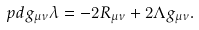<formula> <loc_0><loc_0><loc_500><loc_500>\ p d { g _ { \mu \nu } } \lambda = - 2 R _ { \mu \nu } + 2 \Lambda g _ { \mu \nu } .</formula> 